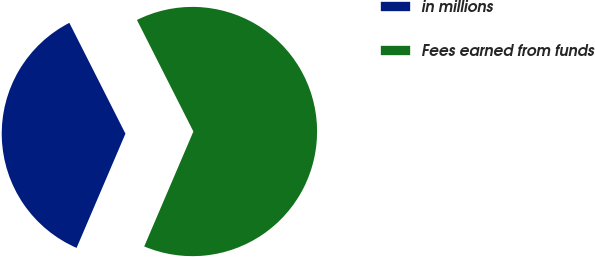Convert chart. <chart><loc_0><loc_0><loc_500><loc_500><pie_chart><fcel>in millions<fcel>Fees earned from funds<nl><fcel>36.11%<fcel>63.89%<nl></chart> 